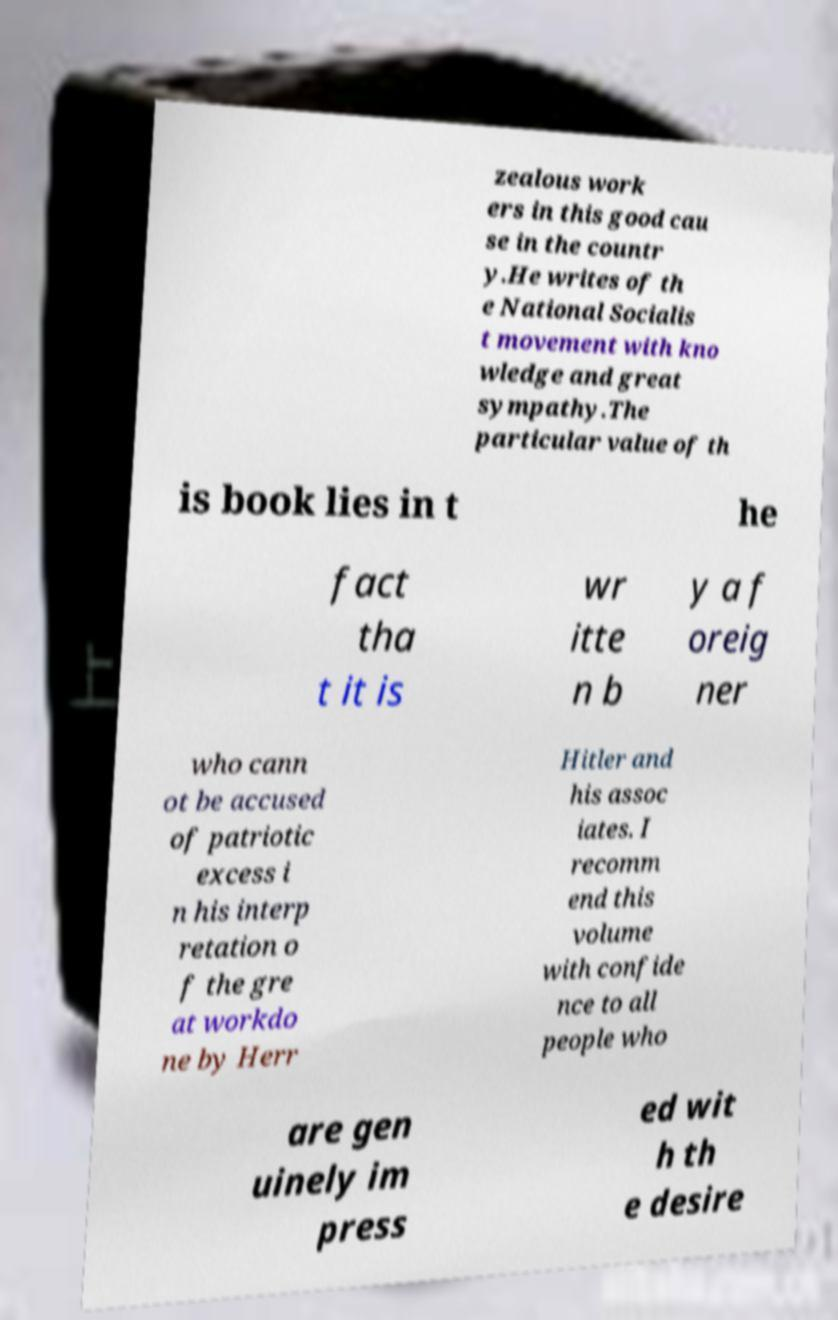What messages or text are displayed in this image? I need them in a readable, typed format. zealous work ers in this good cau se in the countr y.He writes of th e National Socialis t movement with kno wledge and great sympathy.The particular value of th is book lies in t he fact tha t it is wr itte n b y a f oreig ner who cann ot be accused of patriotic excess i n his interp retation o f the gre at workdo ne by Herr Hitler and his assoc iates. I recomm end this volume with confide nce to all people who are gen uinely im press ed wit h th e desire 